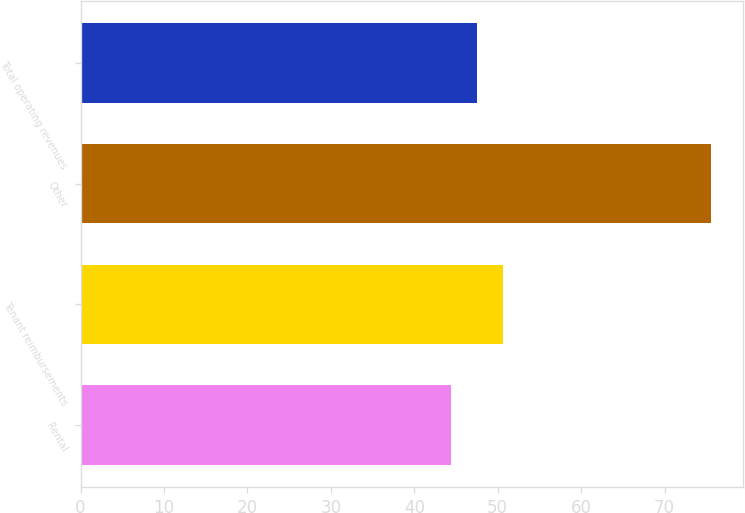Convert chart. <chart><loc_0><loc_0><loc_500><loc_500><bar_chart><fcel>Rental<fcel>Tenant reimbursements<fcel>Other<fcel>Total operating revenues<nl><fcel>44.4<fcel>50.64<fcel>75.6<fcel>47.52<nl></chart> 